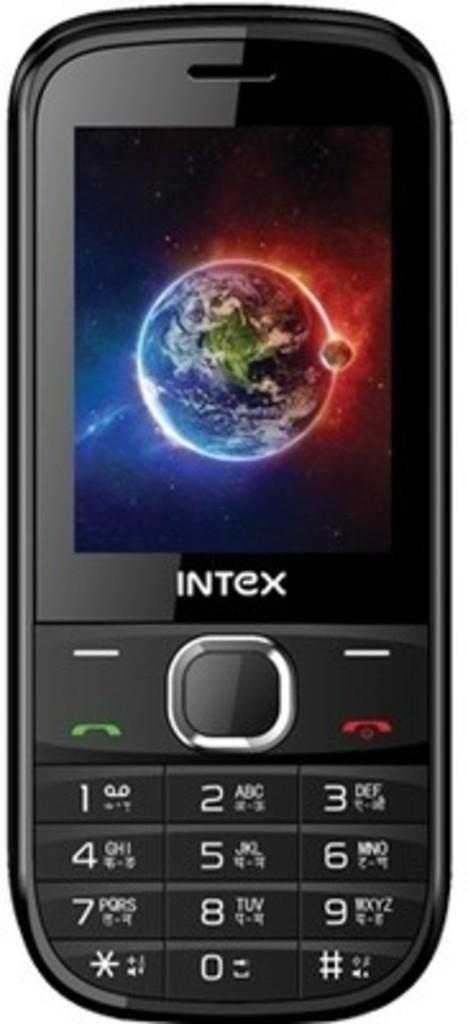<image>
Present a compact description of the photo's key features. A phone made by Intex displays a photo of the Earth. 